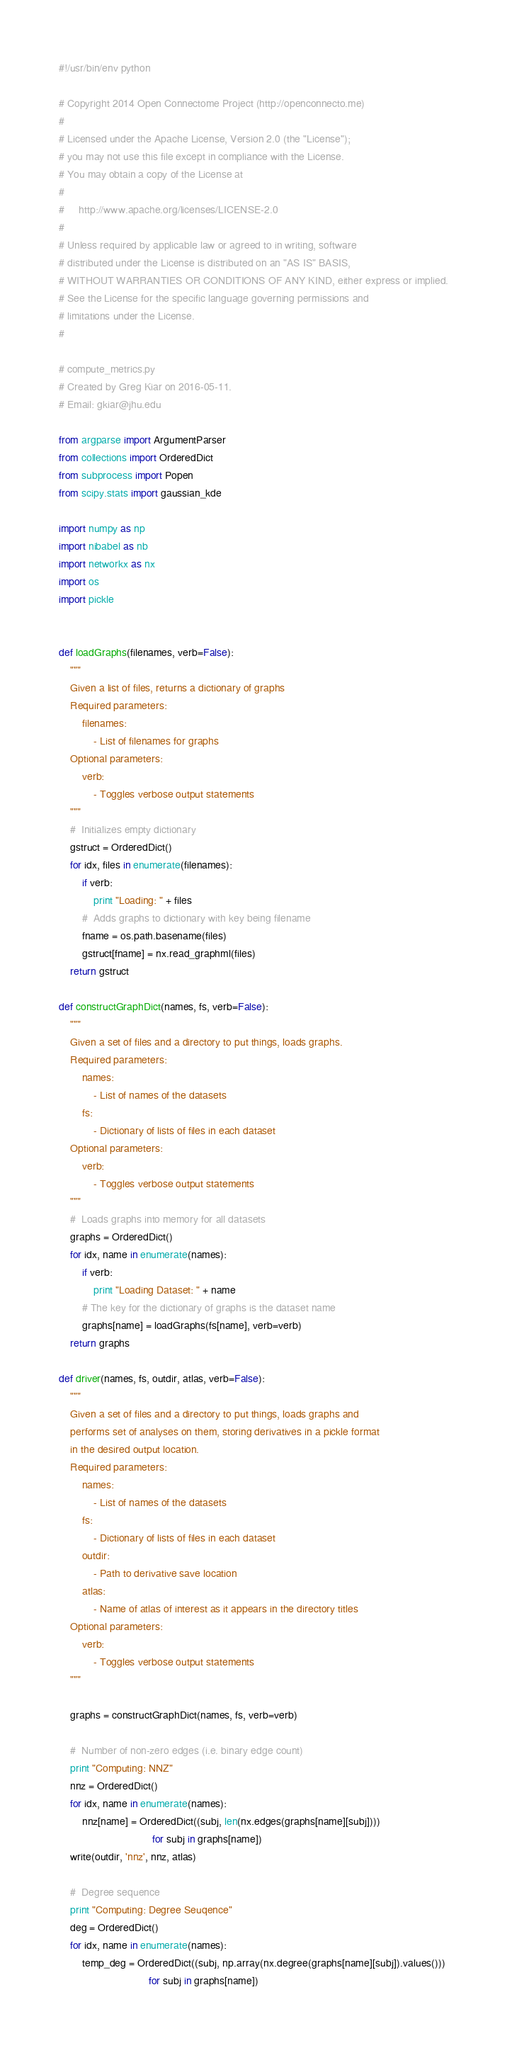Convert code to text. <code><loc_0><loc_0><loc_500><loc_500><_Python_>#!/usr/bin/env python

# Copyright 2014 Open Connectome Project (http://openconnecto.me)
#
# Licensed under the Apache License, Version 2.0 (the "License");
# you may not use this file except in compliance with the License.
# You may obtain a copy of the License at
#
#     http://www.apache.org/licenses/LICENSE-2.0
#
# Unless required by applicable law or agreed to in writing, software
# distributed under the License is distributed on an "AS IS" BASIS,
# WITHOUT WARRANTIES OR CONDITIONS OF ANY KIND, either express or implied.
# See the License for the specific language governing permissions and
# limitations under the License.
#

# compute_metrics.py
# Created by Greg Kiar on 2016-05-11.
# Email: gkiar@jhu.edu

from argparse import ArgumentParser
from collections import OrderedDict
from subprocess import Popen
from scipy.stats import gaussian_kde

import numpy as np
import nibabel as nb
import networkx as nx
import os
import pickle


def loadGraphs(filenames, verb=False):
    """
    Given a list of files, returns a dictionary of graphs
    Required parameters:
        filenames:
            - List of filenames for graphs
    Optional parameters:
        verb:
            - Toggles verbose output statements
    """
    #  Initializes empty dictionary
    gstruct = OrderedDict()
    for idx, files in enumerate(filenames):
        if verb:
            print "Loading: " + files
        #  Adds graphs to dictionary with key being filename
        fname = os.path.basename(files)
        gstruct[fname] = nx.read_graphml(files)
    return gstruct

def constructGraphDict(names, fs, verb=False):
    """
    Given a set of files and a directory to put things, loads graphs.
    Required parameters:
        names:
            - List of names of the datasets
        fs:
            - Dictionary of lists of files in each dataset
    Optional parameters:
        verb:
            - Toggles verbose output statements
    """
    #  Loads graphs into memory for all datasets
    graphs = OrderedDict()
    for idx, name in enumerate(names):
        if verb:
            print "Loading Dataset: " + name
        # The key for the dictionary of graphs is the dataset name
        graphs[name] = loadGraphs(fs[name], verb=verb)
    return graphs

def driver(names, fs, outdir, atlas, verb=False):
    """
    Given a set of files and a directory to put things, loads graphs and
    performs set of analyses on them, storing derivatives in a pickle format
    in the desired output location.
    Required parameters:
        names:
            - List of names of the datasets
        fs:
            - Dictionary of lists of files in each dataset
        outdir:
            - Path to derivative save location
        atlas:
            - Name of atlas of interest as it appears in the directory titles
    Optional parameters:
        verb:
            - Toggles verbose output statements
    """

    graphs = constructGraphDict(names, fs, verb=verb)

    #  Number of non-zero edges (i.e. binary edge count)
    print "Computing: NNZ"
    nnz = OrderedDict()
    for idx, name in enumerate(names):
        nnz[name] = OrderedDict((subj, len(nx.edges(graphs[name][subj])))
                                for subj in graphs[name])
    write(outdir, 'nnz', nnz, atlas)

    #  Degree sequence
    print "Computing: Degree Seuqence"
    deg = OrderedDict()
    for idx, name in enumerate(names):
        temp_deg = OrderedDict((subj, np.array(nx.degree(graphs[name][subj]).values()))
                               for subj in graphs[name])</code> 